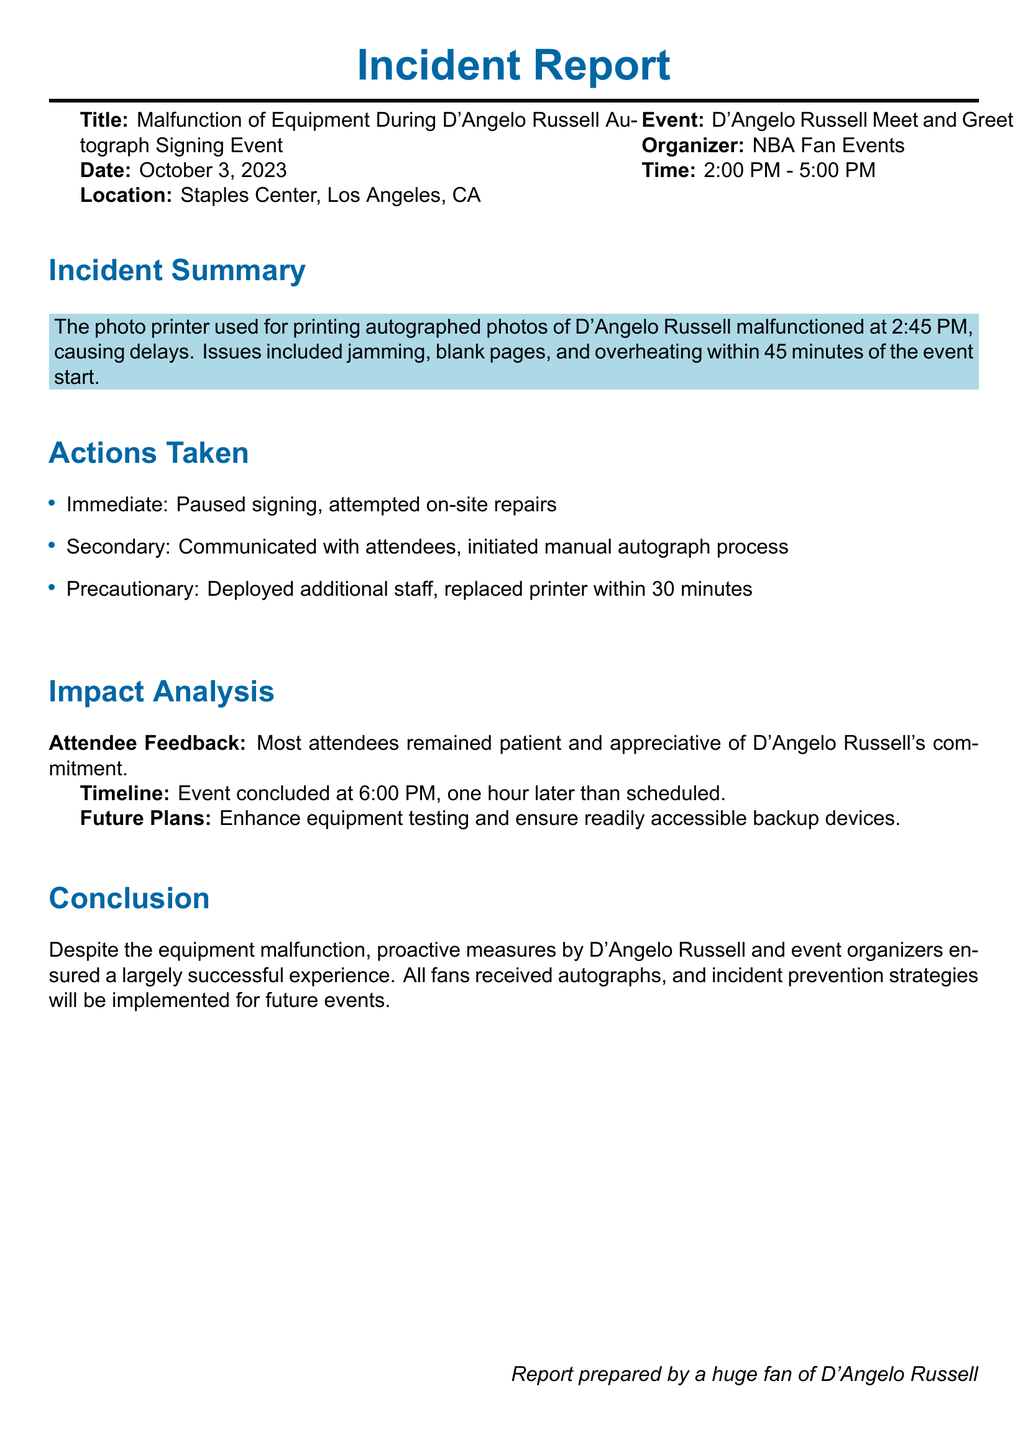What was the date of the incident? The date of the incident is explicitly stated in the document as October 3, 2023.
Answer: October 3, 2023 What type of event was held? The document describes the event as a "D'Angelo Russell Meet and Greet."
Answer: D'Angelo Russell Meet and Greet What time did the event start? The start time of the event is noted as 2:00 PM in the document.
Answer: 2:00 PM What malfunction occurred during the event? The incident report specifically mentions a malfunction of the photo printer used for printing autographed photos.
Answer: Photo printer How long did the delays last? The issues with the printer arose within 45 minutes of the event start, but repairs led to additional delays until 6:00 PM.
Answer: 45 minutes What was one of the immediate actions taken after the malfunction? The immediate action taken was to pause the signing process mentioned in the actions taken section.
Answer: Paused signing What color is used for the section titles in the report? The color used for section titles is specified as lakeblue in the document.
Answer: Lakeblue How many additional staff members were deployed as part of precautionary measures? The document states that additional staff was deployed, but it does not specify a number.
Answer: Not specified What was the conclusion regarding the incident? The conclusion states that despite the malfunction, proactive measures ensured a largely successful experience.
Answer: Largely successful experience 